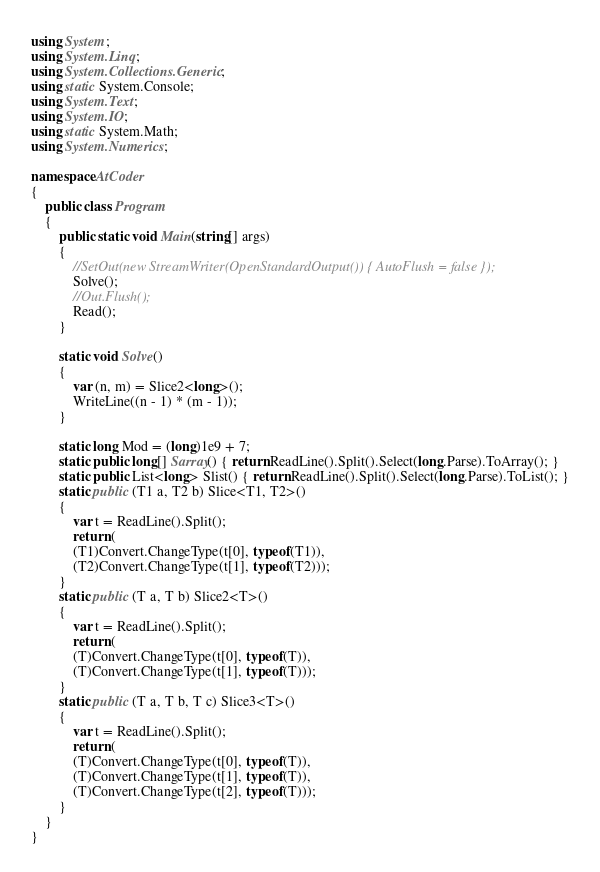<code> <loc_0><loc_0><loc_500><loc_500><_C#_>using System;
using System.Linq;
using System.Collections.Generic;
using static System.Console;
using System.Text;
using System.IO;
using static System.Math;
using System.Numerics;

namespace AtCoder
{
    public class Program
    {
        public static void Main(string[] args)
        {
            //SetOut(new StreamWriter(OpenStandardOutput()) { AutoFlush = false });
            Solve();
            //Out.Flush();
            Read();
        }

        static void Solve()
        {
            var (n, m) = Slice2<long>();
            WriteLine((n - 1) * (m - 1));
        }

        static long Mod = (long)1e9 + 7;
        static public long[] Sarray() { return ReadLine().Split().Select(long.Parse).ToArray(); }
        static public List<long> Slist() { return ReadLine().Split().Select(long.Parse).ToList(); }
        static public (T1 a, T2 b) Slice<T1, T2>()
        {
            var t = ReadLine().Split();
            return (
            (T1)Convert.ChangeType(t[0], typeof(T1)),
            (T2)Convert.ChangeType(t[1], typeof(T2)));
        }
        static public (T a, T b) Slice2<T>()
        {
            var t = ReadLine().Split();
            return (
            (T)Convert.ChangeType(t[0], typeof(T)),
            (T)Convert.ChangeType(t[1], typeof(T)));
        }
        static public (T a, T b, T c) Slice3<T>()
        {
            var t = ReadLine().Split();
            return (
            (T)Convert.ChangeType(t[0], typeof(T)),
            (T)Convert.ChangeType(t[1], typeof(T)),
            (T)Convert.ChangeType(t[2], typeof(T)));
        }
    }
}</code> 